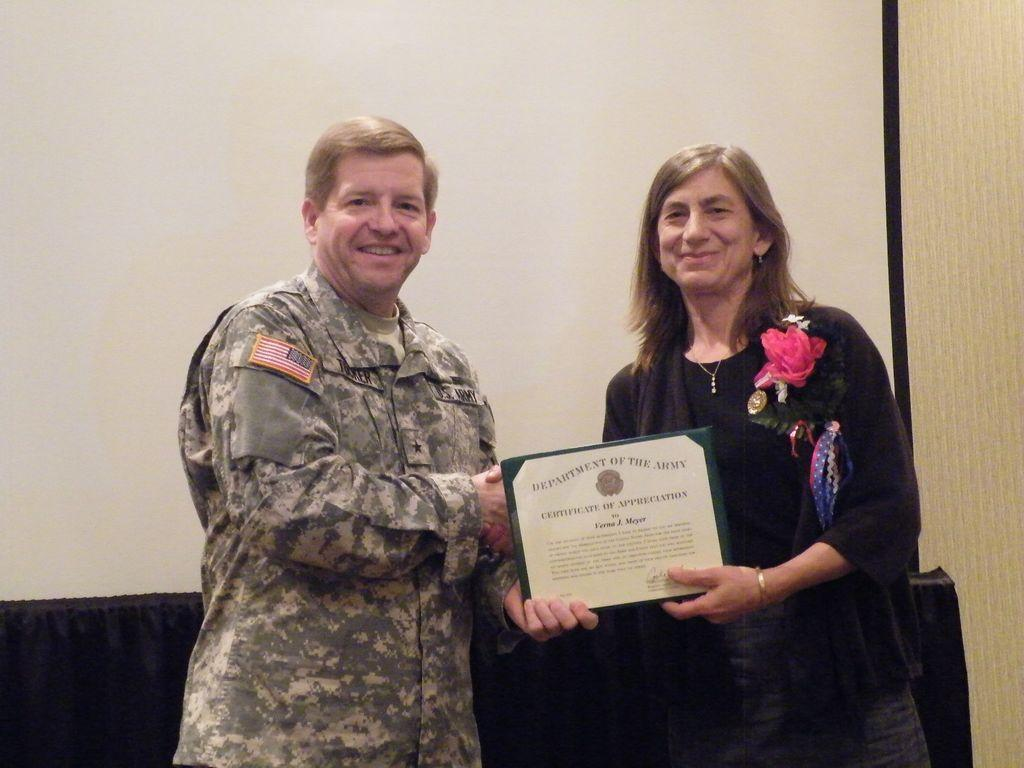How many people are in the image? There are two people in the image. What are the people doing in the image? Both people are laughing. What are the people holding in the image? The two people are holding an award together. What can be seen in the background of the image? There is a projector screen in the background of the image. What type of egg is being used as a mask in the image? There is no egg or mask present in the image. What emotion do the people in the image regret feeling? The people in the image are laughing, so there is no indication of regret. 